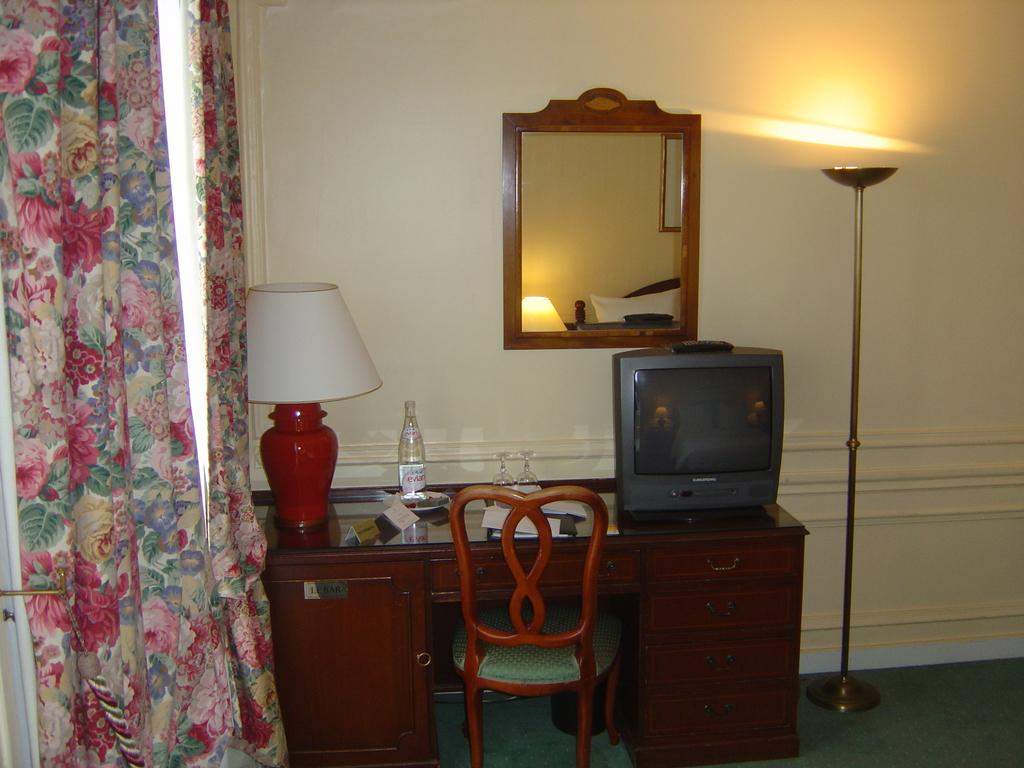What piece of furniture is in the image? There is a table in the image. What electronic device is on the table? A TV is present on the table. What type of tableware can be seen on the table? There are glasses on the table. What beverage container is on the table? There is a bottle on the table. What source of light is on the table? A lamp is on the table. What type of seating is in the image? There is a chair in the image. What can be seen in the background of the image? There is a wall, a light, a mirror, and a curtain in the background of the image. What type of pan is being used to cook in the image? There is no pan or cooking activity present in the image. Can you hear the thunder in the background of the image? There is no mention of thunder or any sound in the image; it is a still picture. 